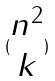Convert formula to latex. <formula><loc_0><loc_0><loc_500><loc_500>( \begin{matrix} n ^ { 2 } \\ k \end{matrix} )</formula> 